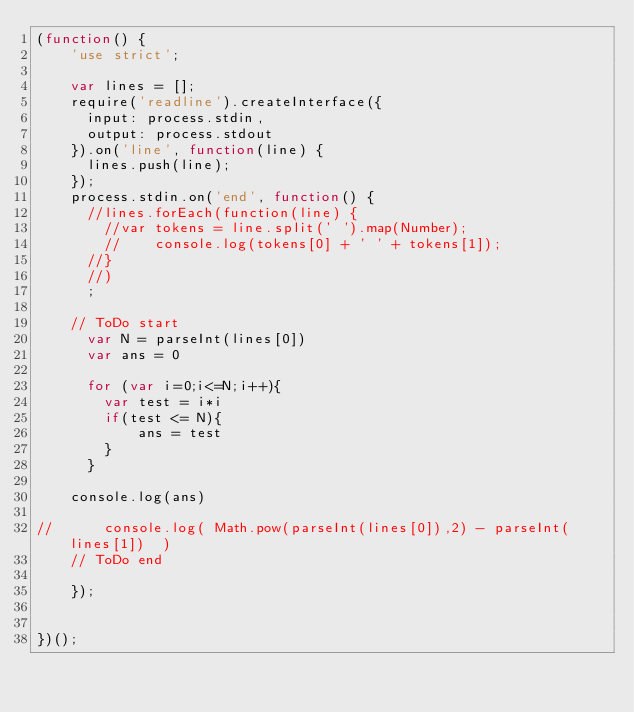Convert code to text. <code><loc_0><loc_0><loc_500><loc_500><_JavaScript_>(function() {
    'use strict';

    var lines = [];
    require('readline').createInterface({
      input: process.stdin,
      output: process.stdout
    }).on('line', function(line) {
      lines.push(line);
    });
    process.stdin.on('end', function() {
      //lines.forEach(function(line) {
        //var tokens = line.split(' ').map(Number);
        //    console.log(tokens[0] + ' ' + tokens[1]);
      //}
      //)
      ;

    // ToDo start
      var N = parseInt(lines[0])
      var ans = 0

      for (var i=0;i<=N;i++){
        var test = i*i
        if(test <= N){
            ans = test
        }
      }

    console.log(ans)
      
//      console.log( Math.pow(parseInt(lines[0]),2) - parseInt(lines[1])  )
    // ToDo end

    });


})();

</code> 